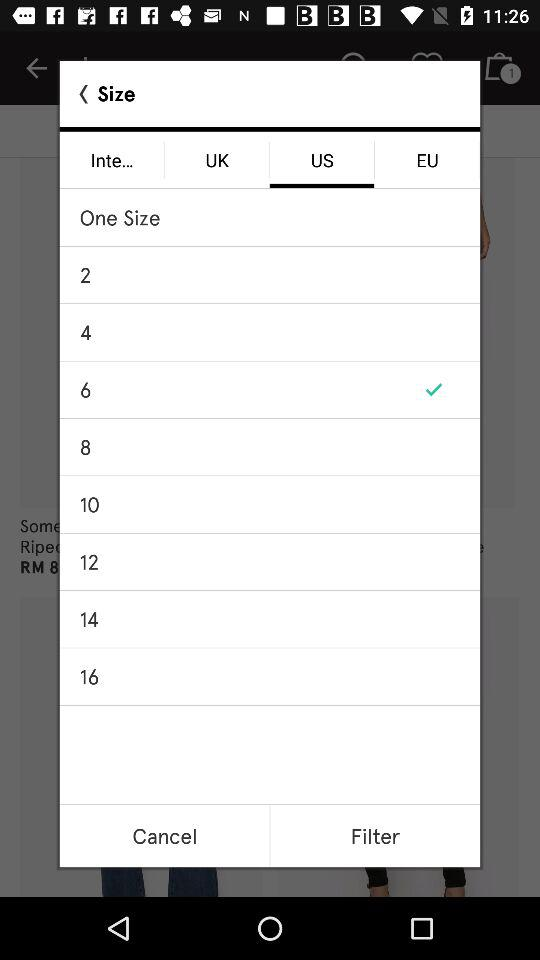Which option is selected in the size category? The selected options in the size category are "US" and "6". 